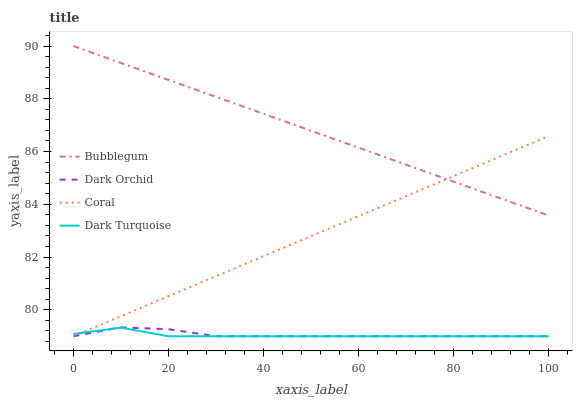Does Coral have the minimum area under the curve?
Answer yes or no. No. Does Coral have the maximum area under the curve?
Answer yes or no. No. Is Dark Orchid the smoothest?
Answer yes or no. No. Is Dark Orchid the roughest?
Answer yes or no. No. Does Bubblegum have the lowest value?
Answer yes or no. No. Does Coral have the highest value?
Answer yes or no. No. Is Dark Orchid less than Bubblegum?
Answer yes or no. Yes. Is Bubblegum greater than Dark Orchid?
Answer yes or no. Yes. Does Dark Orchid intersect Bubblegum?
Answer yes or no. No. 